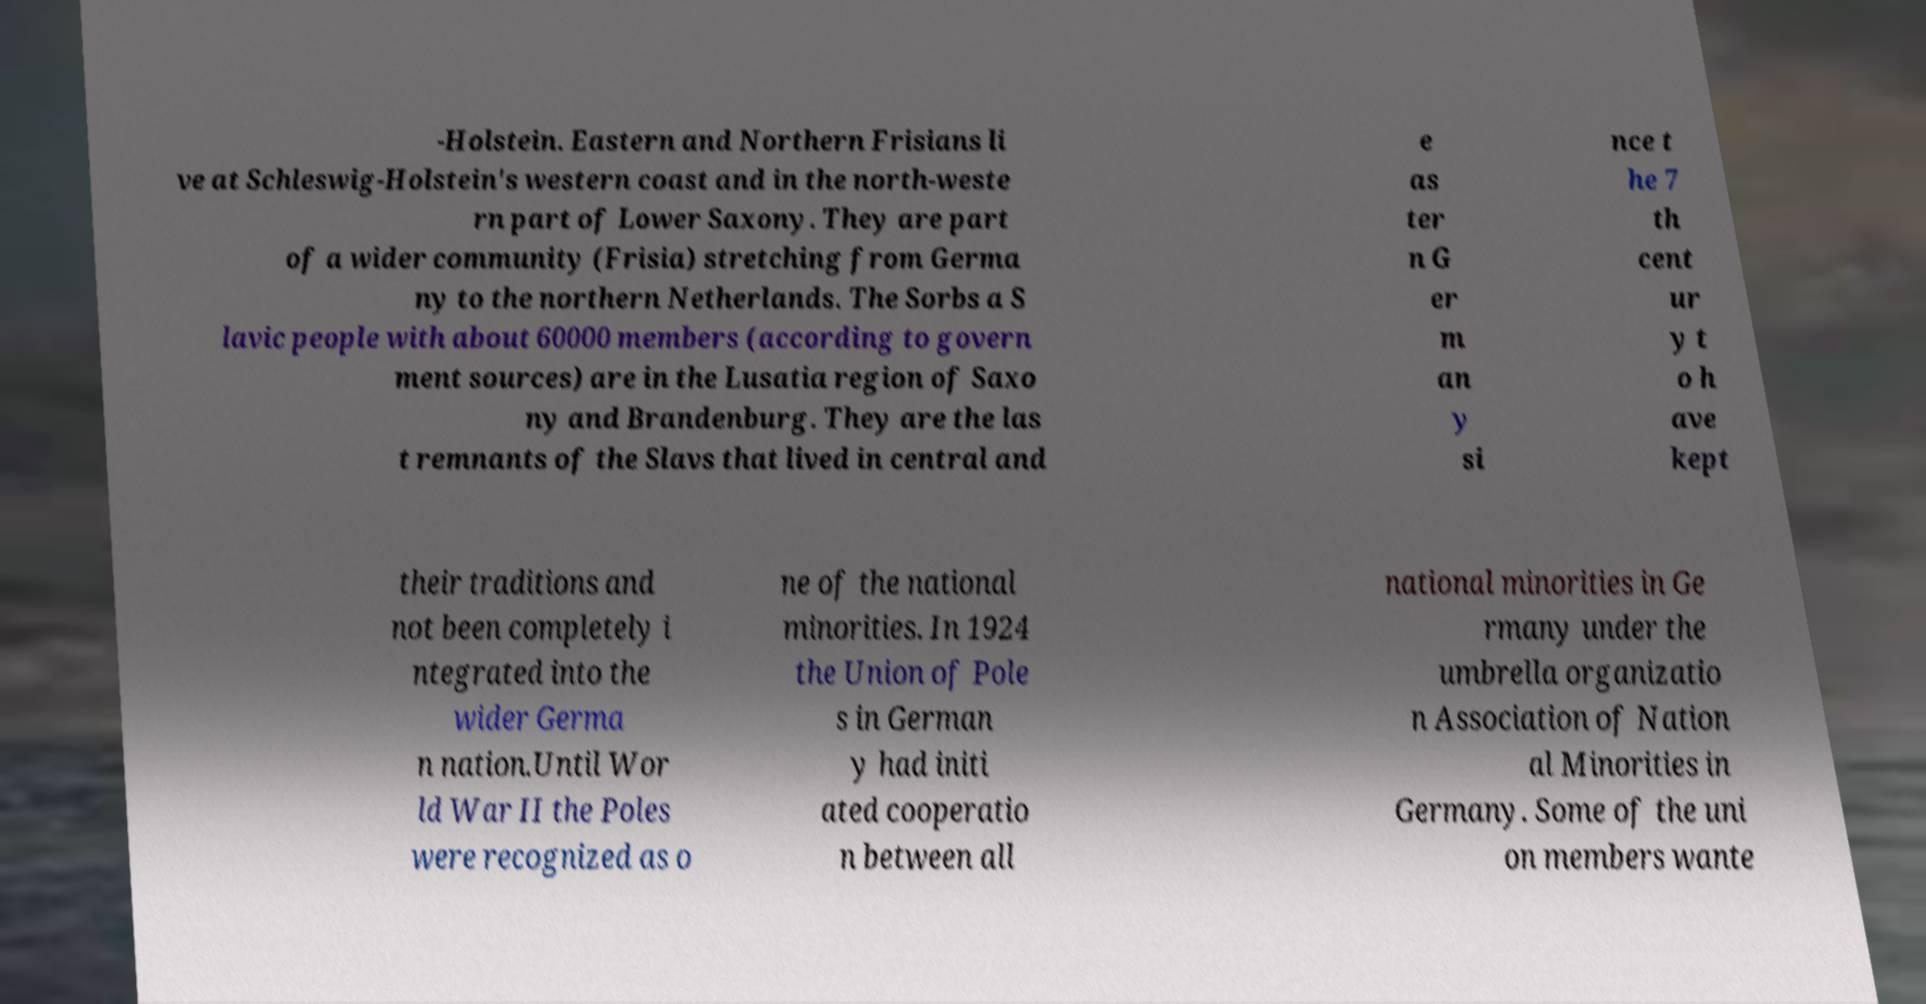I need the written content from this picture converted into text. Can you do that? -Holstein. Eastern and Northern Frisians li ve at Schleswig-Holstein's western coast and in the north-weste rn part of Lower Saxony. They are part of a wider community (Frisia) stretching from Germa ny to the northern Netherlands. The Sorbs a S lavic people with about 60000 members (according to govern ment sources) are in the Lusatia region of Saxo ny and Brandenburg. They are the las t remnants of the Slavs that lived in central and e as ter n G er m an y si nce t he 7 th cent ur y t o h ave kept their traditions and not been completely i ntegrated into the wider Germa n nation.Until Wor ld War II the Poles were recognized as o ne of the national minorities. In 1924 the Union of Pole s in German y had initi ated cooperatio n between all national minorities in Ge rmany under the umbrella organizatio n Association of Nation al Minorities in Germany. Some of the uni on members wante 